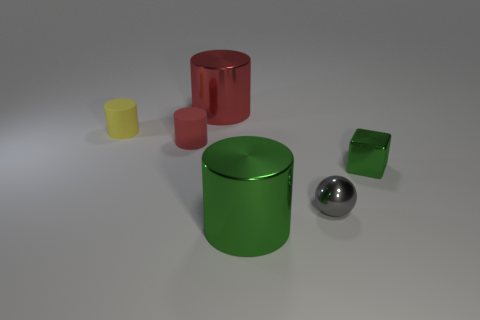Subtract all green cylinders. How many cylinders are left? 3 Subtract all red spheres. How many red cylinders are left? 2 Add 3 tiny shiny cubes. How many objects exist? 9 Subtract all red cylinders. How many cylinders are left? 2 Subtract all spheres. How many objects are left? 5 Add 4 metallic cubes. How many metallic cubes exist? 5 Subtract 2 red cylinders. How many objects are left? 4 Subtract all cyan balls. Subtract all blue cylinders. How many balls are left? 1 Subtract all large red things. Subtract all gray metallic balls. How many objects are left? 4 Add 6 green shiny cubes. How many green shiny cubes are left? 7 